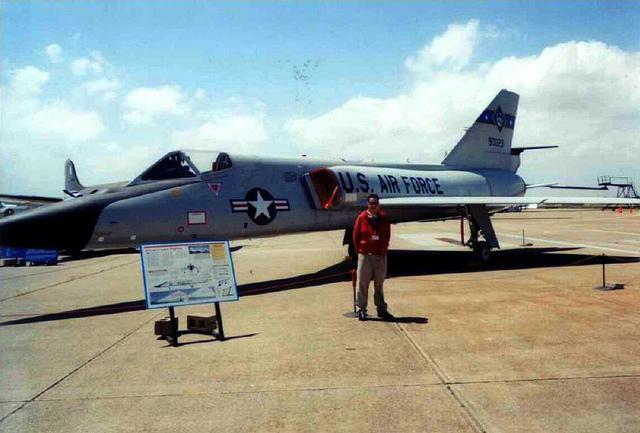How many sheep are shown?
Give a very brief answer. 0. 